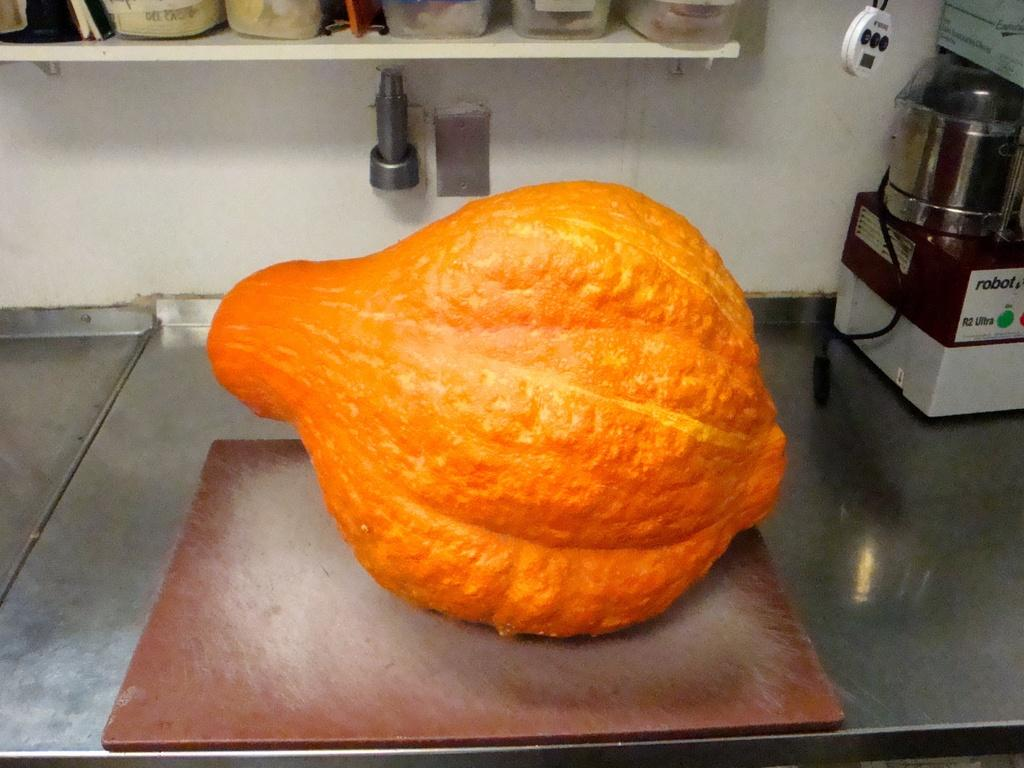<image>
Relay a brief, clear account of the picture shown. Large orange item on top of a brown board and near a machine that says "ROBOT". 